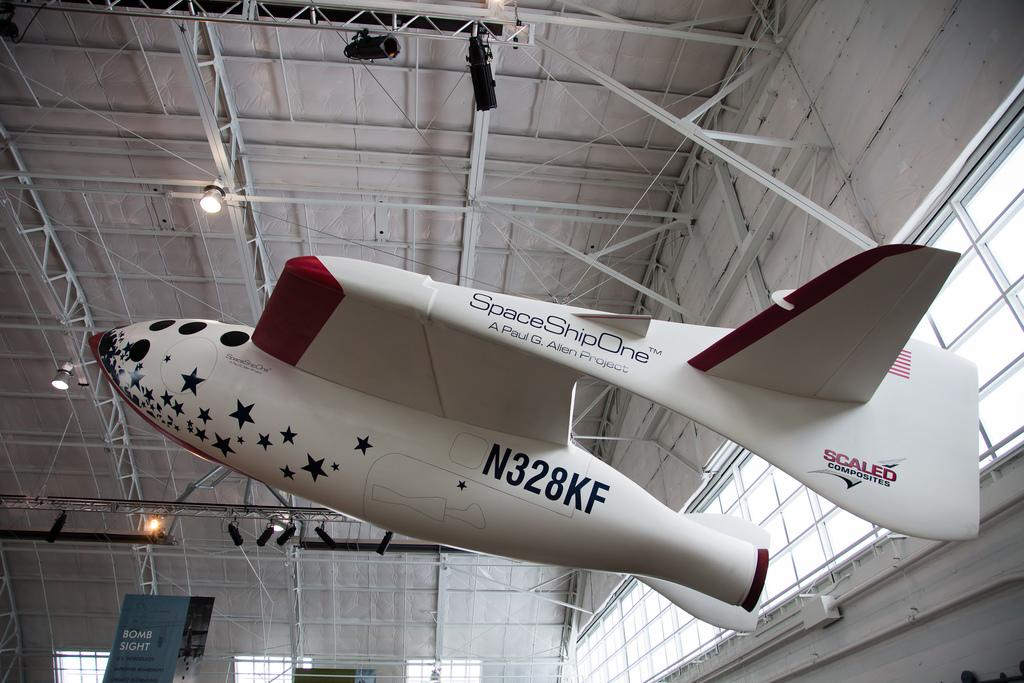<image>
Share a concise interpretation of the image provided. a space vessel called space ship one is hanging from the ceiling 